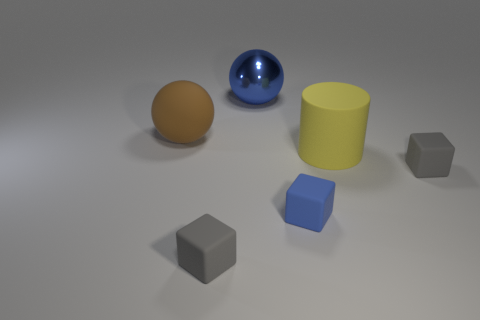The big shiny thing is what color?
Make the answer very short. Blue. What is the color of the large ball on the right side of the tiny matte cube that is left of the metal sphere?
Provide a succinct answer. Blue. Are there any tiny gray blocks that have the same material as the brown sphere?
Keep it short and to the point. Yes. There is a object to the left of the tiny gray object in front of the tiny blue object; what is its material?
Give a very brief answer. Rubber. How many tiny gray rubber objects are the same shape as the large blue metallic object?
Your response must be concise. 0. What is the shape of the large brown matte thing?
Give a very brief answer. Sphere. Are there fewer yellow metallic things than metal balls?
Your response must be concise. Yes. Is there any other thing that is the same size as the blue block?
Provide a succinct answer. Yes. There is another thing that is the same shape as the large brown rubber object; what is its material?
Your response must be concise. Metal. Is the number of large red metal things greater than the number of small objects?
Give a very brief answer. No. 